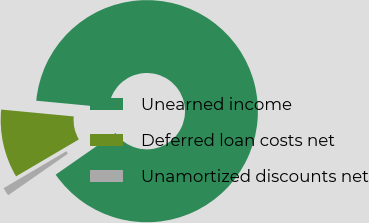<chart> <loc_0><loc_0><loc_500><loc_500><pie_chart><fcel>Unearned income<fcel>Deferred loan costs net<fcel>Unamortized discounts net<nl><fcel>88.82%<fcel>9.97%<fcel>1.21%<nl></chart> 